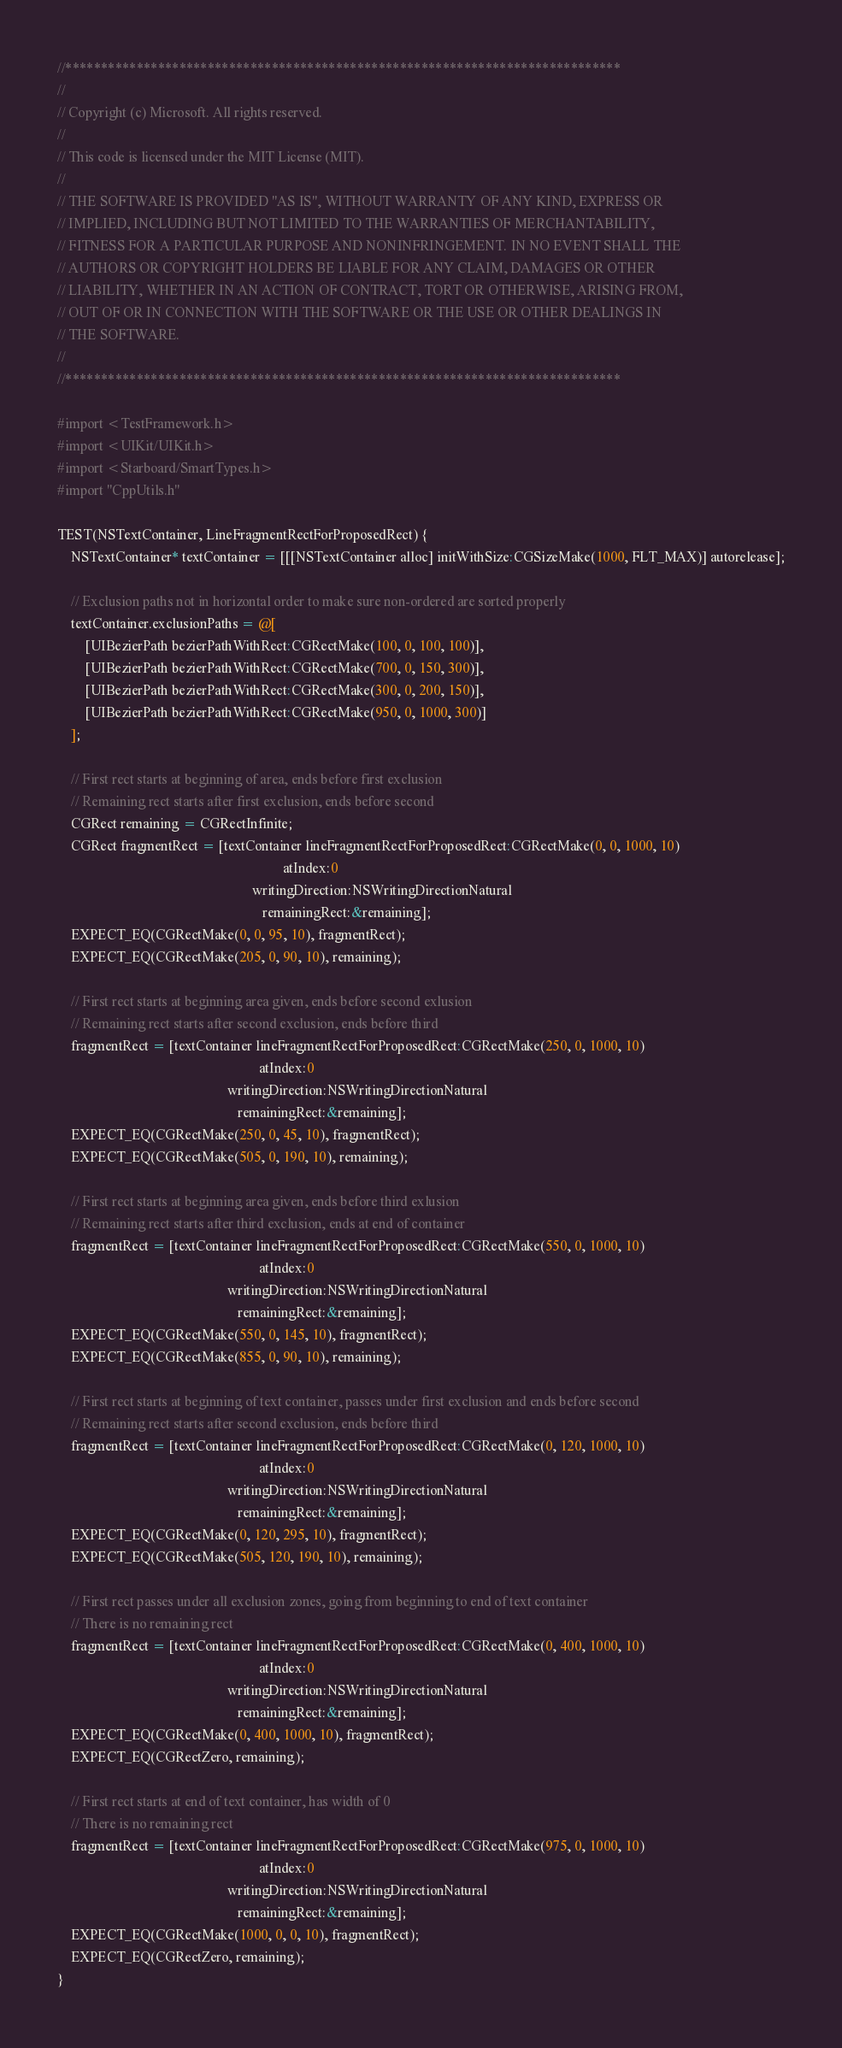Convert code to text. <code><loc_0><loc_0><loc_500><loc_500><_ObjectiveC_>//******************************************************************************
//
// Copyright (c) Microsoft. All rights reserved.
//
// This code is licensed under the MIT License (MIT).
//
// THE SOFTWARE IS PROVIDED "AS IS", WITHOUT WARRANTY OF ANY KIND, EXPRESS OR
// IMPLIED, INCLUDING BUT NOT LIMITED TO THE WARRANTIES OF MERCHANTABILITY,
// FITNESS FOR A PARTICULAR PURPOSE AND NONINFRINGEMENT. IN NO EVENT SHALL THE
// AUTHORS OR COPYRIGHT HOLDERS BE LIABLE FOR ANY CLAIM, DAMAGES OR OTHER
// LIABILITY, WHETHER IN AN ACTION OF CONTRACT, TORT OR OTHERWISE, ARISING FROM,
// OUT OF OR IN CONNECTION WITH THE SOFTWARE OR THE USE OR OTHER DEALINGS IN
// THE SOFTWARE.
//
//******************************************************************************

#import <TestFramework.h>
#import <UIKit/UIKit.h>
#import <Starboard/SmartTypes.h>
#import "CppUtils.h"

TEST(NSTextContainer, LineFragmentRectForProposedRect) {
    NSTextContainer* textContainer = [[[NSTextContainer alloc] initWithSize:CGSizeMake(1000, FLT_MAX)] autorelease];

    // Exclusion paths not in horizontal order to make sure non-ordered are sorted properly
    textContainer.exclusionPaths = @[
        [UIBezierPath bezierPathWithRect:CGRectMake(100, 0, 100, 100)],
        [UIBezierPath bezierPathWithRect:CGRectMake(700, 0, 150, 300)],
        [UIBezierPath bezierPathWithRect:CGRectMake(300, 0, 200, 150)],
        [UIBezierPath bezierPathWithRect:CGRectMake(950, 0, 1000, 300)]
    ];

    // First rect starts at beginning of area, ends before first exclusion
    // Remaining rect starts after first exclusion, ends before second
    CGRect remaining = CGRectInfinite;
    CGRect fragmentRect = [textContainer lineFragmentRectForProposedRect:CGRectMake(0, 0, 1000, 10)
                                                                 atIndex:0
                                                        writingDirection:NSWritingDirectionNatural
                                                           remainingRect:&remaining];
    EXPECT_EQ(CGRectMake(0, 0, 95, 10), fragmentRect);
    EXPECT_EQ(CGRectMake(205, 0, 90, 10), remaining);

    // First rect starts at beginning area given, ends before second exlusion
    // Remaining rect starts after second exclusion, ends before third
    fragmentRect = [textContainer lineFragmentRectForProposedRect:CGRectMake(250, 0, 1000, 10)
                                                          atIndex:0
                                                 writingDirection:NSWritingDirectionNatural
                                                    remainingRect:&remaining];
    EXPECT_EQ(CGRectMake(250, 0, 45, 10), fragmentRect);
    EXPECT_EQ(CGRectMake(505, 0, 190, 10), remaining);

    // First rect starts at beginning area given, ends before third exlusion
    // Remaining rect starts after third exclusion, ends at end of container
    fragmentRect = [textContainer lineFragmentRectForProposedRect:CGRectMake(550, 0, 1000, 10)
                                                          atIndex:0
                                                 writingDirection:NSWritingDirectionNatural
                                                    remainingRect:&remaining];
    EXPECT_EQ(CGRectMake(550, 0, 145, 10), fragmentRect);
    EXPECT_EQ(CGRectMake(855, 0, 90, 10), remaining);

    // First rect starts at beginning of text container, passes under first exclusion and ends before second
    // Remaining rect starts after second exclusion, ends before third
    fragmentRect = [textContainer lineFragmentRectForProposedRect:CGRectMake(0, 120, 1000, 10)
                                                          atIndex:0
                                                 writingDirection:NSWritingDirectionNatural
                                                    remainingRect:&remaining];
    EXPECT_EQ(CGRectMake(0, 120, 295, 10), fragmentRect);
    EXPECT_EQ(CGRectMake(505, 120, 190, 10), remaining);

    // First rect passes under all exclusion zones, going from beginning to end of text container
    // There is no remaining rect
    fragmentRect = [textContainer lineFragmentRectForProposedRect:CGRectMake(0, 400, 1000, 10)
                                                          atIndex:0
                                                 writingDirection:NSWritingDirectionNatural
                                                    remainingRect:&remaining];
    EXPECT_EQ(CGRectMake(0, 400, 1000, 10), fragmentRect);
    EXPECT_EQ(CGRectZero, remaining);

    // First rect starts at end of text container, has width of 0
    // There is no remaining rect
    fragmentRect = [textContainer lineFragmentRectForProposedRect:CGRectMake(975, 0, 1000, 10)
                                                          atIndex:0
                                                 writingDirection:NSWritingDirectionNatural
                                                    remainingRect:&remaining];
    EXPECT_EQ(CGRectMake(1000, 0, 0, 10), fragmentRect);
    EXPECT_EQ(CGRectZero, remaining);
}</code> 